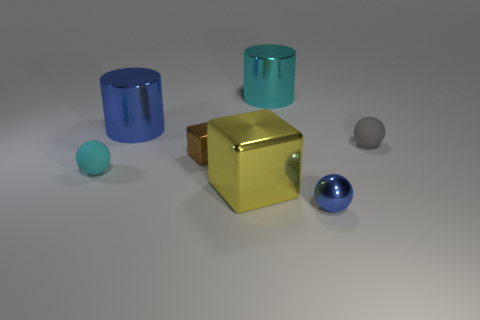Add 3 metallic balls. How many objects exist? 10 Subtract all spheres. How many objects are left? 4 Subtract all tiny blue metal objects. Subtract all gray rubber objects. How many objects are left? 5 Add 2 blocks. How many blocks are left? 4 Add 2 brown metallic things. How many brown metallic things exist? 3 Subtract 0 gray blocks. How many objects are left? 7 